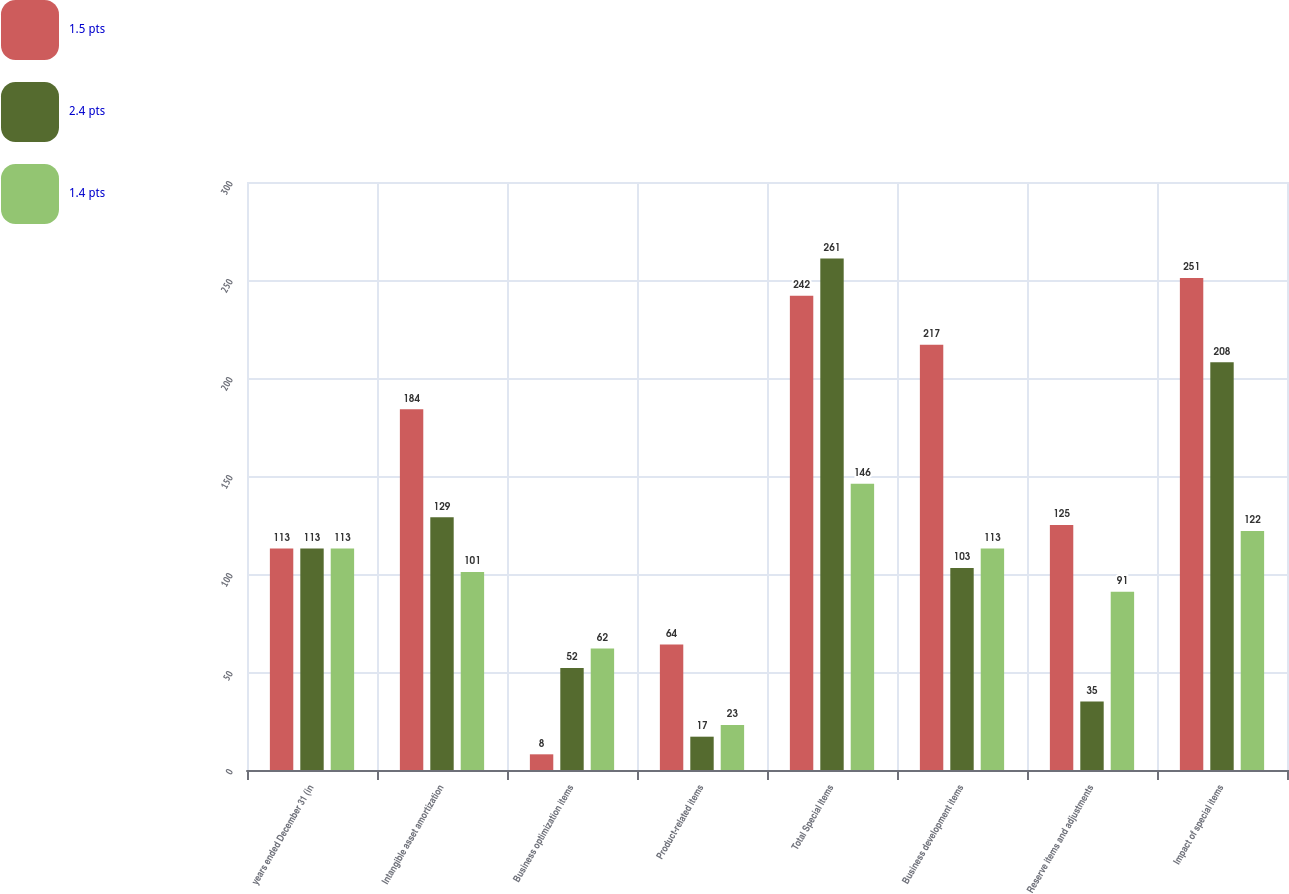<chart> <loc_0><loc_0><loc_500><loc_500><stacked_bar_chart><ecel><fcel>years ended December 31 (in<fcel>Intangible asset amortization<fcel>Business optimization items<fcel>Product-related items<fcel>Total Special Items<fcel>Business development items<fcel>Reserve items and adjustments<fcel>Impact of special items<nl><fcel>1.5 pts<fcel>113<fcel>184<fcel>8<fcel>64<fcel>242<fcel>217<fcel>125<fcel>251<nl><fcel>2.4 pts<fcel>113<fcel>129<fcel>52<fcel>17<fcel>261<fcel>103<fcel>35<fcel>208<nl><fcel>1.4 pts<fcel>113<fcel>101<fcel>62<fcel>23<fcel>146<fcel>113<fcel>91<fcel>122<nl></chart> 